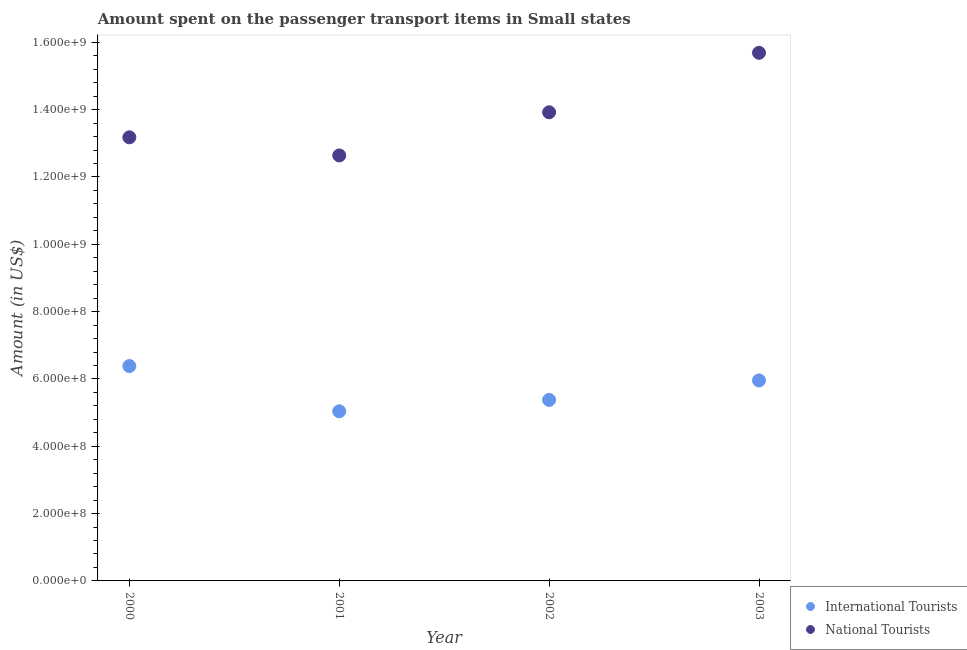Is the number of dotlines equal to the number of legend labels?
Provide a short and direct response. Yes. What is the amount spent on transport items of international tourists in 2000?
Ensure brevity in your answer.  6.38e+08. Across all years, what is the maximum amount spent on transport items of international tourists?
Provide a succinct answer. 6.38e+08. Across all years, what is the minimum amount spent on transport items of national tourists?
Your answer should be very brief. 1.26e+09. In which year was the amount spent on transport items of national tourists minimum?
Provide a succinct answer. 2001. What is the total amount spent on transport items of national tourists in the graph?
Keep it short and to the point. 5.54e+09. What is the difference between the amount spent on transport items of international tourists in 2001 and that in 2002?
Make the answer very short. -3.39e+07. What is the difference between the amount spent on transport items of international tourists in 2003 and the amount spent on transport items of national tourists in 2001?
Your response must be concise. -6.68e+08. What is the average amount spent on transport items of international tourists per year?
Offer a very short reply. 5.69e+08. In the year 2003, what is the difference between the amount spent on transport items of national tourists and amount spent on transport items of international tourists?
Your answer should be very brief. 9.73e+08. In how many years, is the amount spent on transport items of national tourists greater than 160000000 US$?
Your response must be concise. 4. What is the ratio of the amount spent on transport items of national tourists in 2000 to that in 2001?
Your answer should be compact. 1.04. Is the amount spent on transport items of national tourists in 2000 less than that in 2003?
Offer a very short reply. Yes. What is the difference between the highest and the second highest amount spent on transport items of international tourists?
Your answer should be very brief. 4.28e+07. What is the difference between the highest and the lowest amount spent on transport items of national tourists?
Ensure brevity in your answer.  3.05e+08. In how many years, is the amount spent on transport items of national tourists greater than the average amount spent on transport items of national tourists taken over all years?
Provide a short and direct response. 2. Is the sum of the amount spent on transport items of national tourists in 2001 and 2002 greater than the maximum amount spent on transport items of international tourists across all years?
Your answer should be very brief. Yes. Is the amount spent on transport items of international tourists strictly greater than the amount spent on transport items of national tourists over the years?
Offer a very short reply. No. Is the amount spent on transport items of international tourists strictly less than the amount spent on transport items of national tourists over the years?
Make the answer very short. Yes. How many dotlines are there?
Provide a short and direct response. 2. How many years are there in the graph?
Offer a very short reply. 4. Are the values on the major ticks of Y-axis written in scientific E-notation?
Provide a succinct answer. Yes. How many legend labels are there?
Offer a terse response. 2. How are the legend labels stacked?
Your answer should be very brief. Vertical. What is the title of the graph?
Make the answer very short. Amount spent on the passenger transport items in Small states. What is the Amount (in US$) in International Tourists in 2000?
Provide a succinct answer. 6.38e+08. What is the Amount (in US$) of National Tourists in 2000?
Offer a very short reply. 1.32e+09. What is the Amount (in US$) in International Tourists in 2001?
Your answer should be compact. 5.04e+08. What is the Amount (in US$) in National Tourists in 2001?
Your answer should be compact. 1.26e+09. What is the Amount (in US$) in International Tourists in 2002?
Offer a very short reply. 5.38e+08. What is the Amount (in US$) in National Tourists in 2002?
Give a very brief answer. 1.39e+09. What is the Amount (in US$) in International Tourists in 2003?
Give a very brief answer. 5.95e+08. What is the Amount (in US$) of National Tourists in 2003?
Your answer should be compact. 1.57e+09. Across all years, what is the maximum Amount (in US$) of International Tourists?
Offer a terse response. 6.38e+08. Across all years, what is the maximum Amount (in US$) of National Tourists?
Ensure brevity in your answer.  1.57e+09. Across all years, what is the minimum Amount (in US$) of International Tourists?
Your answer should be very brief. 5.04e+08. Across all years, what is the minimum Amount (in US$) in National Tourists?
Offer a terse response. 1.26e+09. What is the total Amount (in US$) of International Tourists in the graph?
Keep it short and to the point. 2.28e+09. What is the total Amount (in US$) in National Tourists in the graph?
Provide a short and direct response. 5.54e+09. What is the difference between the Amount (in US$) of International Tourists in 2000 and that in 2001?
Your response must be concise. 1.34e+08. What is the difference between the Amount (in US$) in National Tourists in 2000 and that in 2001?
Provide a succinct answer. 5.38e+07. What is the difference between the Amount (in US$) of International Tourists in 2000 and that in 2002?
Provide a succinct answer. 1.01e+08. What is the difference between the Amount (in US$) in National Tourists in 2000 and that in 2002?
Ensure brevity in your answer.  -7.44e+07. What is the difference between the Amount (in US$) of International Tourists in 2000 and that in 2003?
Your answer should be very brief. 4.28e+07. What is the difference between the Amount (in US$) of National Tourists in 2000 and that in 2003?
Your response must be concise. -2.51e+08. What is the difference between the Amount (in US$) of International Tourists in 2001 and that in 2002?
Ensure brevity in your answer.  -3.39e+07. What is the difference between the Amount (in US$) in National Tourists in 2001 and that in 2002?
Keep it short and to the point. -1.28e+08. What is the difference between the Amount (in US$) in International Tourists in 2001 and that in 2003?
Ensure brevity in your answer.  -9.16e+07. What is the difference between the Amount (in US$) in National Tourists in 2001 and that in 2003?
Make the answer very short. -3.05e+08. What is the difference between the Amount (in US$) of International Tourists in 2002 and that in 2003?
Your answer should be compact. -5.77e+07. What is the difference between the Amount (in US$) of National Tourists in 2002 and that in 2003?
Offer a terse response. -1.77e+08. What is the difference between the Amount (in US$) of International Tourists in 2000 and the Amount (in US$) of National Tourists in 2001?
Keep it short and to the point. -6.26e+08. What is the difference between the Amount (in US$) in International Tourists in 2000 and the Amount (in US$) in National Tourists in 2002?
Your answer should be very brief. -7.54e+08. What is the difference between the Amount (in US$) of International Tourists in 2000 and the Amount (in US$) of National Tourists in 2003?
Give a very brief answer. -9.31e+08. What is the difference between the Amount (in US$) of International Tourists in 2001 and the Amount (in US$) of National Tourists in 2002?
Your answer should be very brief. -8.88e+08. What is the difference between the Amount (in US$) of International Tourists in 2001 and the Amount (in US$) of National Tourists in 2003?
Provide a succinct answer. -1.06e+09. What is the difference between the Amount (in US$) in International Tourists in 2002 and the Amount (in US$) in National Tourists in 2003?
Ensure brevity in your answer.  -1.03e+09. What is the average Amount (in US$) in International Tourists per year?
Make the answer very short. 5.69e+08. What is the average Amount (in US$) of National Tourists per year?
Your answer should be very brief. 1.39e+09. In the year 2000, what is the difference between the Amount (in US$) in International Tourists and Amount (in US$) in National Tourists?
Give a very brief answer. -6.80e+08. In the year 2001, what is the difference between the Amount (in US$) of International Tourists and Amount (in US$) of National Tourists?
Make the answer very short. -7.60e+08. In the year 2002, what is the difference between the Amount (in US$) in International Tourists and Amount (in US$) in National Tourists?
Provide a succinct answer. -8.54e+08. In the year 2003, what is the difference between the Amount (in US$) in International Tourists and Amount (in US$) in National Tourists?
Keep it short and to the point. -9.73e+08. What is the ratio of the Amount (in US$) in International Tourists in 2000 to that in 2001?
Your response must be concise. 1.27. What is the ratio of the Amount (in US$) of National Tourists in 2000 to that in 2001?
Keep it short and to the point. 1.04. What is the ratio of the Amount (in US$) in International Tourists in 2000 to that in 2002?
Offer a terse response. 1.19. What is the ratio of the Amount (in US$) of National Tourists in 2000 to that in 2002?
Your response must be concise. 0.95. What is the ratio of the Amount (in US$) in International Tourists in 2000 to that in 2003?
Provide a short and direct response. 1.07. What is the ratio of the Amount (in US$) of National Tourists in 2000 to that in 2003?
Offer a terse response. 0.84. What is the ratio of the Amount (in US$) in International Tourists in 2001 to that in 2002?
Your response must be concise. 0.94. What is the ratio of the Amount (in US$) in National Tourists in 2001 to that in 2002?
Offer a terse response. 0.91. What is the ratio of the Amount (in US$) in International Tourists in 2001 to that in 2003?
Your response must be concise. 0.85. What is the ratio of the Amount (in US$) of National Tourists in 2001 to that in 2003?
Offer a very short reply. 0.81. What is the ratio of the Amount (in US$) of International Tourists in 2002 to that in 2003?
Keep it short and to the point. 0.9. What is the ratio of the Amount (in US$) in National Tourists in 2002 to that in 2003?
Offer a very short reply. 0.89. What is the difference between the highest and the second highest Amount (in US$) in International Tourists?
Offer a terse response. 4.28e+07. What is the difference between the highest and the second highest Amount (in US$) of National Tourists?
Your answer should be very brief. 1.77e+08. What is the difference between the highest and the lowest Amount (in US$) in International Tourists?
Your answer should be very brief. 1.34e+08. What is the difference between the highest and the lowest Amount (in US$) of National Tourists?
Make the answer very short. 3.05e+08. 